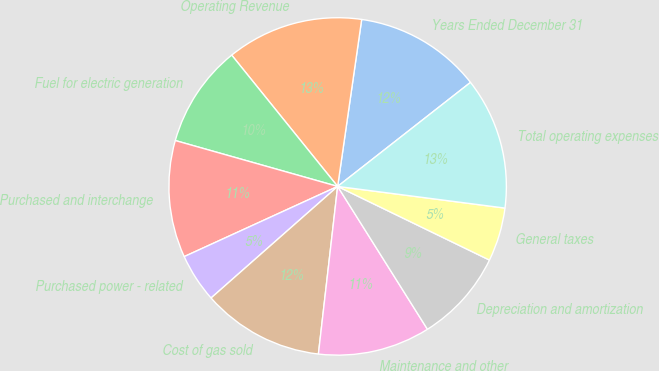<chart> <loc_0><loc_0><loc_500><loc_500><pie_chart><fcel>Years Ended December 31<fcel>Operating Revenue<fcel>Fuel for electric generation<fcel>Purchased and interchange<fcel>Purchased power - related<fcel>Cost of gas sold<fcel>Maintenance and other<fcel>Depreciation and amortization<fcel>General taxes<fcel>Total operating expenses<nl><fcel>12.15%<fcel>13.08%<fcel>9.81%<fcel>11.21%<fcel>4.67%<fcel>11.68%<fcel>10.75%<fcel>8.88%<fcel>5.14%<fcel>12.62%<nl></chart> 